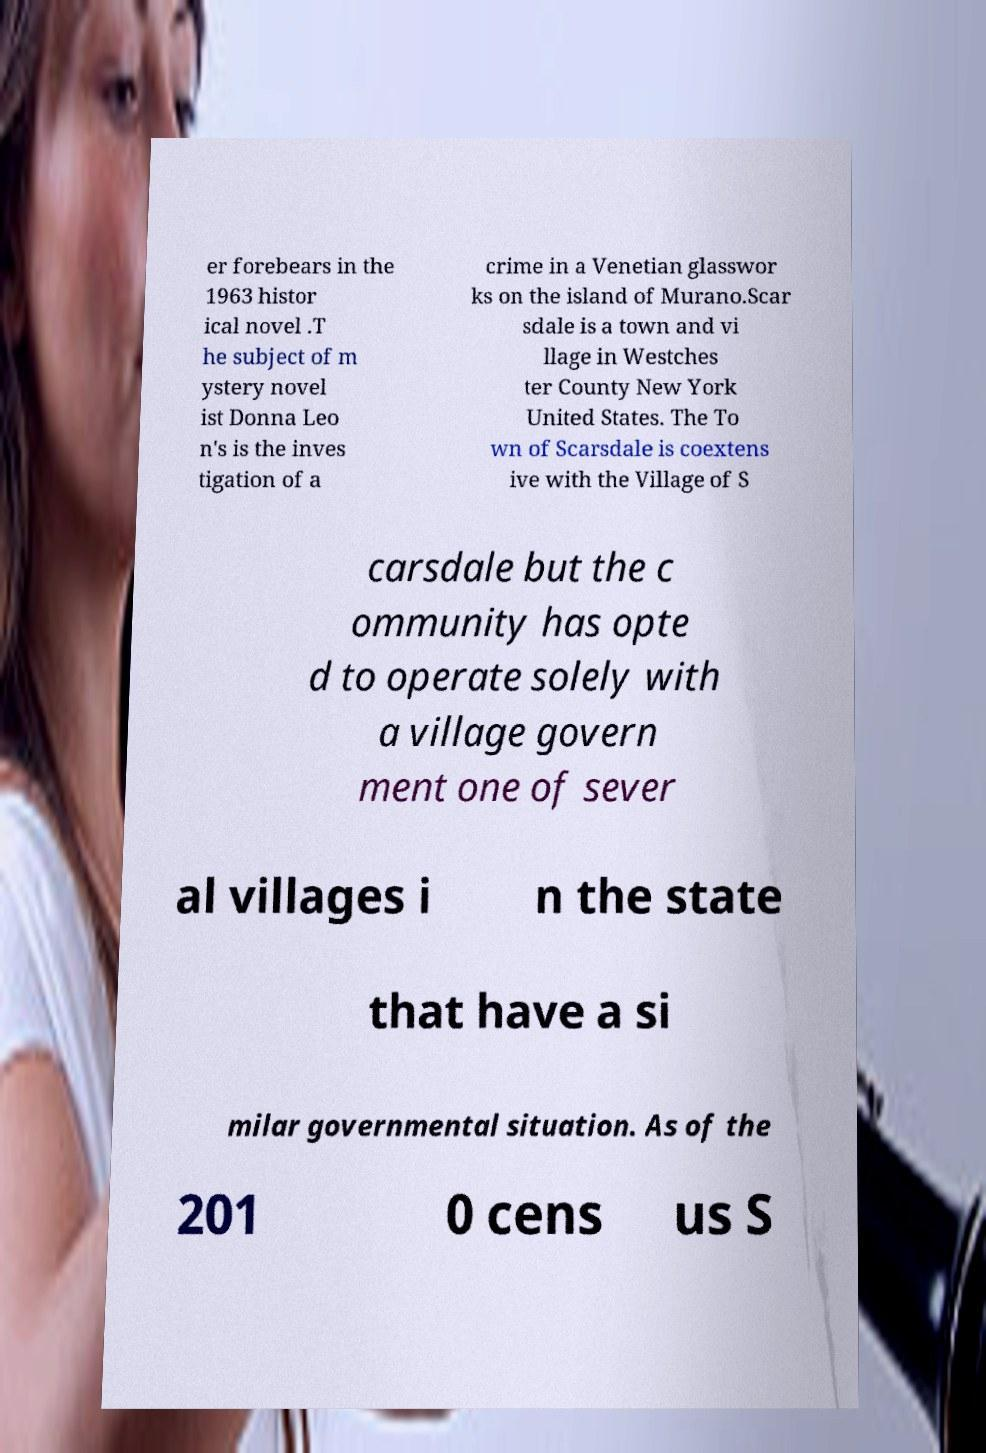Could you extract and type out the text from this image? er forebears in the 1963 histor ical novel .T he subject of m ystery novel ist Donna Leo n's is the inves tigation of a crime in a Venetian glasswor ks on the island of Murano.Scar sdale is a town and vi llage in Westches ter County New York United States. The To wn of Scarsdale is coextens ive with the Village of S carsdale but the c ommunity has opte d to operate solely with a village govern ment one of sever al villages i n the state that have a si milar governmental situation. As of the 201 0 cens us S 